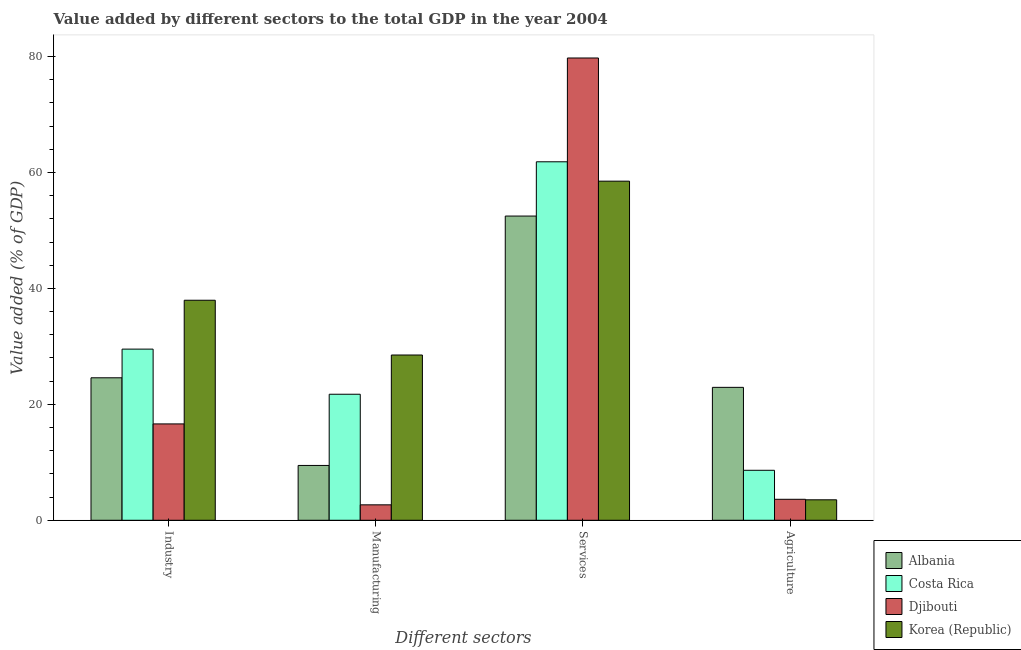How many different coloured bars are there?
Give a very brief answer. 4. How many groups of bars are there?
Make the answer very short. 4. Are the number of bars on each tick of the X-axis equal?
Your answer should be compact. Yes. What is the label of the 3rd group of bars from the left?
Keep it short and to the point. Services. What is the value added by services sector in Costa Rica?
Make the answer very short. 61.85. Across all countries, what is the maximum value added by manufacturing sector?
Offer a terse response. 28.51. Across all countries, what is the minimum value added by services sector?
Provide a short and direct response. 52.49. In which country was the value added by manufacturing sector minimum?
Keep it short and to the point. Djibouti. What is the total value added by agricultural sector in the graph?
Provide a short and direct response. 38.7. What is the difference between the value added by manufacturing sector in Costa Rica and that in Korea (Republic)?
Provide a short and direct response. -6.77. What is the difference between the value added by services sector in Djibouti and the value added by agricultural sector in Costa Rica?
Keep it short and to the point. 71.14. What is the average value added by industrial sector per country?
Offer a terse response. 27.17. What is the difference between the value added by agricultural sector and value added by industrial sector in Korea (Republic)?
Your response must be concise. -34.43. What is the ratio of the value added by industrial sector in Costa Rica to that in Albania?
Keep it short and to the point. 1.2. Is the value added by manufacturing sector in Costa Rica less than that in Djibouti?
Offer a very short reply. No. Is the difference between the value added by manufacturing sector in Djibouti and Albania greater than the difference between the value added by agricultural sector in Djibouti and Albania?
Ensure brevity in your answer.  Yes. What is the difference between the highest and the second highest value added by manufacturing sector?
Provide a short and direct response. 6.77. What is the difference between the highest and the lowest value added by manufacturing sector?
Ensure brevity in your answer.  25.85. In how many countries, is the value added by agricultural sector greater than the average value added by agricultural sector taken over all countries?
Make the answer very short. 1. What does the 1st bar from the left in Industry represents?
Make the answer very short. Albania. What does the 4th bar from the right in Manufacturing represents?
Offer a terse response. Albania. How many countries are there in the graph?
Provide a succinct answer. 4. Are the values on the major ticks of Y-axis written in scientific E-notation?
Your answer should be compact. No. Does the graph contain grids?
Keep it short and to the point. No. How are the legend labels stacked?
Keep it short and to the point. Vertical. What is the title of the graph?
Provide a succinct answer. Value added by different sectors to the total GDP in the year 2004. What is the label or title of the X-axis?
Your answer should be compact. Different sectors. What is the label or title of the Y-axis?
Make the answer very short. Value added (% of GDP). What is the Value added (% of GDP) in Albania in Industry?
Ensure brevity in your answer.  24.58. What is the Value added (% of GDP) in Costa Rica in Industry?
Keep it short and to the point. 29.53. What is the Value added (% of GDP) of Djibouti in Industry?
Give a very brief answer. 16.62. What is the Value added (% of GDP) of Korea (Republic) in Industry?
Keep it short and to the point. 37.96. What is the Value added (% of GDP) of Albania in Manufacturing?
Ensure brevity in your answer.  9.46. What is the Value added (% of GDP) in Costa Rica in Manufacturing?
Your answer should be very brief. 21.74. What is the Value added (% of GDP) of Djibouti in Manufacturing?
Ensure brevity in your answer.  2.66. What is the Value added (% of GDP) in Korea (Republic) in Manufacturing?
Give a very brief answer. 28.51. What is the Value added (% of GDP) of Albania in Services?
Your response must be concise. 52.49. What is the Value added (% of GDP) of Costa Rica in Services?
Ensure brevity in your answer.  61.85. What is the Value added (% of GDP) in Djibouti in Services?
Make the answer very short. 79.76. What is the Value added (% of GDP) of Korea (Republic) in Services?
Make the answer very short. 58.51. What is the Value added (% of GDP) in Albania in Agriculture?
Your answer should be very brief. 22.93. What is the Value added (% of GDP) in Costa Rica in Agriculture?
Your answer should be compact. 8.62. What is the Value added (% of GDP) in Djibouti in Agriculture?
Provide a short and direct response. 3.62. What is the Value added (% of GDP) in Korea (Republic) in Agriculture?
Your answer should be compact. 3.53. Across all Different sectors, what is the maximum Value added (% of GDP) in Albania?
Give a very brief answer. 52.49. Across all Different sectors, what is the maximum Value added (% of GDP) of Costa Rica?
Provide a succinct answer. 61.85. Across all Different sectors, what is the maximum Value added (% of GDP) of Djibouti?
Provide a succinct answer. 79.76. Across all Different sectors, what is the maximum Value added (% of GDP) in Korea (Republic)?
Ensure brevity in your answer.  58.51. Across all Different sectors, what is the minimum Value added (% of GDP) of Albania?
Make the answer very short. 9.46. Across all Different sectors, what is the minimum Value added (% of GDP) of Costa Rica?
Offer a very short reply. 8.62. Across all Different sectors, what is the minimum Value added (% of GDP) of Djibouti?
Offer a very short reply. 2.66. Across all Different sectors, what is the minimum Value added (% of GDP) of Korea (Republic)?
Offer a terse response. 3.53. What is the total Value added (% of GDP) of Albania in the graph?
Your answer should be compact. 109.46. What is the total Value added (% of GDP) of Costa Rica in the graph?
Your answer should be very brief. 121.74. What is the total Value added (% of GDP) in Djibouti in the graph?
Offer a terse response. 102.66. What is the total Value added (% of GDP) of Korea (Republic) in the graph?
Provide a succinct answer. 128.51. What is the difference between the Value added (% of GDP) in Albania in Industry and that in Manufacturing?
Offer a terse response. 15.12. What is the difference between the Value added (% of GDP) of Costa Rica in Industry and that in Manufacturing?
Ensure brevity in your answer.  7.78. What is the difference between the Value added (% of GDP) in Djibouti in Industry and that in Manufacturing?
Your answer should be compact. 13.96. What is the difference between the Value added (% of GDP) of Korea (Republic) in Industry and that in Manufacturing?
Your response must be concise. 9.45. What is the difference between the Value added (% of GDP) of Albania in Industry and that in Services?
Your answer should be compact. -27.9. What is the difference between the Value added (% of GDP) in Costa Rica in Industry and that in Services?
Provide a succinct answer. -32.32. What is the difference between the Value added (% of GDP) of Djibouti in Industry and that in Services?
Your answer should be very brief. -63.14. What is the difference between the Value added (% of GDP) of Korea (Republic) in Industry and that in Services?
Offer a very short reply. -20.54. What is the difference between the Value added (% of GDP) of Albania in Industry and that in Agriculture?
Offer a very short reply. 1.65. What is the difference between the Value added (% of GDP) of Costa Rica in Industry and that in Agriculture?
Keep it short and to the point. 20.9. What is the difference between the Value added (% of GDP) in Djibouti in Industry and that in Agriculture?
Provide a short and direct response. 13. What is the difference between the Value added (% of GDP) of Korea (Republic) in Industry and that in Agriculture?
Provide a succinct answer. 34.43. What is the difference between the Value added (% of GDP) of Albania in Manufacturing and that in Services?
Give a very brief answer. -43.03. What is the difference between the Value added (% of GDP) of Costa Rica in Manufacturing and that in Services?
Make the answer very short. -40.1. What is the difference between the Value added (% of GDP) of Djibouti in Manufacturing and that in Services?
Give a very brief answer. -77.1. What is the difference between the Value added (% of GDP) of Korea (Republic) in Manufacturing and that in Services?
Offer a terse response. -29.99. What is the difference between the Value added (% of GDP) in Albania in Manufacturing and that in Agriculture?
Your answer should be compact. -13.47. What is the difference between the Value added (% of GDP) of Costa Rica in Manufacturing and that in Agriculture?
Provide a short and direct response. 13.12. What is the difference between the Value added (% of GDP) of Djibouti in Manufacturing and that in Agriculture?
Your answer should be very brief. -0.96. What is the difference between the Value added (% of GDP) in Korea (Republic) in Manufacturing and that in Agriculture?
Offer a very short reply. 24.98. What is the difference between the Value added (% of GDP) of Albania in Services and that in Agriculture?
Your answer should be very brief. 29.55. What is the difference between the Value added (% of GDP) of Costa Rica in Services and that in Agriculture?
Your answer should be compact. 53.23. What is the difference between the Value added (% of GDP) of Djibouti in Services and that in Agriculture?
Your response must be concise. 76.14. What is the difference between the Value added (% of GDP) in Korea (Republic) in Services and that in Agriculture?
Give a very brief answer. 54.98. What is the difference between the Value added (% of GDP) of Albania in Industry and the Value added (% of GDP) of Costa Rica in Manufacturing?
Provide a succinct answer. 2.84. What is the difference between the Value added (% of GDP) of Albania in Industry and the Value added (% of GDP) of Djibouti in Manufacturing?
Make the answer very short. 21.92. What is the difference between the Value added (% of GDP) of Albania in Industry and the Value added (% of GDP) of Korea (Republic) in Manufacturing?
Give a very brief answer. -3.93. What is the difference between the Value added (% of GDP) of Costa Rica in Industry and the Value added (% of GDP) of Djibouti in Manufacturing?
Offer a very short reply. 26.87. What is the difference between the Value added (% of GDP) of Costa Rica in Industry and the Value added (% of GDP) of Korea (Republic) in Manufacturing?
Keep it short and to the point. 1.01. What is the difference between the Value added (% of GDP) in Djibouti in Industry and the Value added (% of GDP) in Korea (Republic) in Manufacturing?
Your answer should be very brief. -11.89. What is the difference between the Value added (% of GDP) of Albania in Industry and the Value added (% of GDP) of Costa Rica in Services?
Offer a terse response. -37.27. What is the difference between the Value added (% of GDP) of Albania in Industry and the Value added (% of GDP) of Djibouti in Services?
Keep it short and to the point. -55.18. What is the difference between the Value added (% of GDP) in Albania in Industry and the Value added (% of GDP) in Korea (Republic) in Services?
Make the answer very short. -33.93. What is the difference between the Value added (% of GDP) in Costa Rica in Industry and the Value added (% of GDP) in Djibouti in Services?
Provide a short and direct response. -50.23. What is the difference between the Value added (% of GDP) of Costa Rica in Industry and the Value added (% of GDP) of Korea (Republic) in Services?
Provide a succinct answer. -28.98. What is the difference between the Value added (% of GDP) in Djibouti in Industry and the Value added (% of GDP) in Korea (Republic) in Services?
Provide a short and direct response. -41.88. What is the difference between the Value added (% of GDP) in Albania in Industry and the Value added (% of GDP) in Costa Rica in Agriculture?
Your answer should be compact. 15.96. What is the difference between the Value added (% of GDP) of Albania in Industry and the Value added (% of GDP) of Djibouti in Agriculture?
Your answer should be very brief. 20.96. What is the difference between the Value added (% of GDP) of Albania in Industry and the Value added (% of GDP) of Korea (Republic) in Agriculture?
Make the answer very short. 21.05. What is the difference between the Value added (% of GDP) of Costa Rica in Industry and the Value added (% of GDP) of Djibouti in Agriculture?
Your response must be concise. 25.91. What is the difference between the Value added (% of GDP) of Costa Rica in Industry and the Value added (% of GDP) of Korea (Republic) in Agriculture?
Your response must be concise. 26. What is the difference between the Value added (% of GDP) of Djibouti in Industry and the Value added (% of GDP) of Korea (Republic) in Agriculture?
Your answer should be compact. 13.09. What is the difference between the Value added (% of GDP) in Albania in Manufacturing and the Value added (% of GDP) in Costa Rica in Services?
Your answer should be compact. -52.39. What is the difference between the Value added (% of GDP) of Albania in Manufacturing and the Value added (% of GDP) of Djibouti in Services?
Provide a short and direct response. -70.3. What is the difference between the Value added (% of GDP) of Albania in Manufacturing and the Value added (% of GDP) of Korea (Republic) in Services?
Provide a short and direct response. -49.05. What is the difference between the Value added (% of GDP) of Costa Rica in Manufacturing and the Value added (% of GDP) of Djibouti in Services?
Give a very brief answer. -58.01. What is the difference between the Value added (% of GDP) of Costa Rica in Manufacturing and the Value added (% of GDP) of Korea (Republic) in Services?
Provide a short and direct response. -36.76. What is the difference between the Value added (% of GDP) in Djibouti in Manufacturing and the Value added (% of GDP) in Korea (Republic) in Services?
Offer a very short reply. -55.85. What is the difference between the Value added (% of GDP) of Albania in Manufacturing and the Value added (% of GDP) of Costa Rica in Agriculture?
Give a very brief answer. 0.83. What is the difference between the Value added (% of GDP) of Albania in Manufacturing and the Value added (% of GDP) of Djibouti in Agriculture?
Your response must be concise. 5.84. What is the difference between the Value added (% of GDP) of Albania in Manufacturing and the Value added (% of GDP) of Korea (Republic) in Agriculture?
Offer a terse response. 5.93. What is the difference between the Value added (% of GDP) in Costa Rica in Manufacturing and the Value added (% of GDP) in Djibouti in Agriculture?
Make the answer very short. 18.13. What is the difference between the Value added (% of GDP) of Costa Rica in Manufacturing and the Value added (% of GDP) of Korea (Republic) in Agriculture?
Provide a succinct answer. 18.21. What is the difference between the Value added (% of GDP) of Djibouti in Manufacturing and the Value added (% of GDP) of Korea (Republic) in Agriculture?
Provide a succinct answer. -0.87. What is the difference between the Value added (% of GDP) in Albania in Services and the Value added (% of GDP) in Costa Rica in Agriculture?
Your answer should be compact. 43.86. What is the difference between the Value added (% of GDP) of Albania in Services and the Value added (% of GDP) of Djibouti in Agriculture?
Ensure brevity in your answer.  48.87. What is the difference between the Value added (% of GDP) in Albania in Services and the Value added (% of GDP) in Korea (Republic) in Agriculture?
Provide a short and direct response. 48.96. What is the difference between the Value added (% of GDP) of Costa Rica in Services and the Value added (% of GDP) of Djibouti in Agriculture?
Offer a very short reply. 58.23. What is the difference between the Value added (% of GDP) of Costa Rica in Services and the Value added (% of GDP) of Korea (Republic) in Agriculture?
Offer a very short reply. 58.32. What is the difference between the Value added (% of GDP) of Djibouti in Services and the Value added (% of GDP) of Korea (Republic) in Agriculture?
Your answer should be compact. 76.23. What is the average Value added (% of GDP) of Albania per Different sectors?
Provide a short and direct response. 27.36. What is the average Value added (% of GDP) of Costa Rica per Different sectors?
Provide a succinct answer. 30.44. What is the average Value added (% of GDP) of Djibouti per Different sectors?
Ensure brevity in your answer.  25.67. What is the average Value added (% of GDP) in Korea (Republic) per Different sectors?
Make the answer very short. 32.13. What is the difference between the Value added (% of GDP) in Albania and Value added (% of GDP) in Costa Rica in Industry?
Provide a succinct answer. -4.95. What is the difference between the Value added (% of GDP) in Albania and Value added (% of GDP) in Djibouti in Industry?
Your response must be concise. 7.96. What is the difference between the Value added (% of GDP) in Albania and Value added (% of GDP) in Korea (Republic) in Industry?
Give a very brief answer. -13.38. What is the difference between the Value added (% of GDP) in Costa Rica and Value added (% of GDP) in Djibouti in Industry?
Keep it short and to the point. 12.91. What is the difference between the Value added (% of GDP) of Costa Rica and Value added (% of GDP) of Korea (Republic) in Industry?
Make the answer very short. -8.43. What is the difference between the Value added (% of GDP) in Djibouti and Value added (% of GDP) in Korea (Republic) in Industry?
Your answer should be very brief. -21.34. What is the difference between the Value added (% of GDP) of Albania and Value added (% of GDP) of Costa Rica in Manufacturing?
Provide a succinct answer. -12.29. What is the difference between the Value added (% of GDP) of Albania and Value added (% of GDP) of Djibouti in Manufacturing?
Keep it short and to the point. 6.8. What is the difference between the Value added (% of GDP) in Albania and Value added (% of GDP) in Korea (Republic) in Manufacturing?
Offer a terse response. -19.06. What is the difference between the Value added (% of GDP) of Costa Rica and Value added (% of GDP) of Djibouti in Manufacturing?
Keep it short and to the point. 19.08. What is the difference between the Value added (% of GDP) in Costa Rica and Value added (% of GDP) in Korea (Republic) in Manufacturing?
Keep it short and to the point. -6.77. What is the difference between the Value added (% of GDP) in Djibouti and Value added (% of GDP) in Korea (Republic) in Manufacturing?
Ensure brevity in your answer.  -25.85. What is the difference between the Value added (% of GDP) in Albania and Value added (% of GDP) in Costa Rica in Services?
Your response must be concise. -9.36. What is the difference between the Value added (% of GDP) in Albania and Value added (% of GDP) in Djibouti in Services?
Your answer should be very brief. -27.27. What is the difference between the Value added (% of GDP) in Albania and Value added (% of GDP) in Korea (Republic) in Services?
Give a very brief answer. -6.02. What is the difference between the Value added (% of GDP) in Costa Rica and Value added (% of GDP) in Djibouti in Services?
Ensure brevity in your answer.  -17.91. What is the difference between the Value added (% of GDP) of Costa Rica and Value added (% of GDP) of Korea (Republic) in Services?
Your answer should be compact. 3.34. What is the difference between the Value added (% of GDP) of Djibouti and Value added (% of GDP) of Korea (Republic) in Services?
Make the answer very short. 21.25. What is the difference between the Value added (% of GDP) of Albania and Value added (% of GDP) of Costa Rica in Agriculture?
Provide a short and direct response. 14.31. What is the difference between the Value added (% of GDP) of Albania and Value added (% of GDP) of Djibouti in Agriculture?
Offer a terse response. 19.31. What is the difference between the Value added (% of GDP) of Albania and Value added (% of GDP) of Korea (Republic) in Agriculture?
Give a very brief answer. 19.4. What is the difference between the Value added (% of GDP) of Costa Rica and Value added (% of GDP) of Djibouti in Agriculture?
Give a very brief answer. 5. What is the difference between the Value added (% of GDP) of Costa Rica and Value added (% of GDP) of Korea (Republic) in Agriculture?
Offer a very short reply. 5.09. What is the difference between the Value added (% of GDP) in Djibouti and Value added (% of GDP) in Korea (Republic) in Agriculture?
Give a very brief answer. 0.09. What is the ratio of the Value added (% of GDP) of Albania in Industry to that in Manufacturing?
Your response must be concise. 2.6. What is the ratio of the Value added (% of GDP) in Costa Rica in Industry to that in Manufacturing?
Ensure brevity in your answer.  1.36. What is the ratio of the Value added (% of GDP) of Djibouti in Industry to that in Manufacturing?
Keep it short and to the point. 6.25. What is the ratio of the Value added (% of GDP) of Korea (Republic) in Industry to that in Manufacturing?
Provide a short and direct response. 1.33. What is the ratio of the Value added (% of GDP) in Albania in Industry to that in Services?
Your response must be concise. 0.47. What is the ratio of the Value added (% of GDP) of Costa Rica in Industry to that in Services?
Your answer should be compact. 0.48. What is the ratio of the Value added (% of GDP) of Djibouti in Industry to that in Services?
Offer a terse response. 0.21. What is the ratio of the Value added (% of GDP) in Korea (Republic) in Industry to that in Services?
Provide a succinct answer. 0.65. What is the ratio of the Value added (% of GDP) of Albania in Industry to that in Agriculture?
Your response must be concise. 1.07. What is the ratio of the Value added (% of GDP) of Costa Rica in Industry to that in Agriculture?
Offer a terse response. 3.42. What is the ratio of the Value added (% of GDP) in Djibouti in Industry to that in Agriculture?
Provide a succinct answer. 4.59. What is the ratio of the Value added (% of GDP) of Korea (Republic) in Industry to that in Agriculture?
Give a very brief answer. 10.75. What is the ratio of the Value added (% of GDP) of Albania in Manufacturing to that in Services?
Ensure brevity in your answer.  0.18. What is the ratio of the Value added (% of GDP) in Costa Rica in Manufacturing to that in Services?
Keep it short and to the point. 0.35. What is the ratio of the Value added (% of GDP) in Djibouti in Manufacturing to that in Services?
Give a very brief answer. 0.03. What is the ratio of the Value added (% of GDP) in Korea (Republic) in Manufacturing to that in Services?
Provide a succinct answer. 0.49. What is the ratio of the Value added (% of GDP) of Albania in Manufacturing to that in Agriculture?
Offer a very short reply. 0.41. What is the ratio of the Value added (% of GDP) of Costa Rica in Manufacturing to that in Agriculture?
Your answer should be very brief. 2.52. What is the ratio of the Value added (% of GDP) in Djibouti in Manufacturing to that in Agriculture?
Offer a terse response. 0.74. What is the ratio of the Value added (% of GDP) in Korea (Republic) in Manufacturing to that in Agriculture?
Your answer should be very brief. 8.08. What is the ratio of the Value added (% of GDP) of Albania in Services to that in Agriculture?
Provide a succinct answer. 2.29. What is the ratio of the Value added (% of GDP) in Costa Rica in Services to that in Agriculture?
Offer a terse response. 7.17. What is the ratio of the Value added (% of GDP) of Djibouti in Services to that in Agriculture?
Provide a succinct answer. 22.04. What is the ratio of the Value added (% of GDP) of Korea (Republic) in Services to that in Agriculture?
Give a very brief answer. 16.57. What is the difference between the highest and the second highest Value added (% of GDP) of Albania?
Your response must be concise. 27.9. What is the difference between the highest and the second highest Value added (% of GDP) in Costa Rica?
Offer a very short reply. 32.32. What is the difference between the highest and the second highest Value added (% of GDP) of Djibouti?
Make the answer very short. 63.14. What is the difference between the highest and the second highest Value added (% of GDP) in Korea (Republic)?
Keep it short and to the point. 20.54. What is the difference between the highest and the lowest Value added (% of GDP) of Albania?
Give a very brief answer. 43.03. What is the difference between the highest and the lowest Value added (% of GDP) of Costa Rica?
Offer a very short reply. 53.23. What is the difference between the highest and the lowest Value added (% of GDP) of Djibouti?
Offer a terse response. 77.1. What is the difference between the highest and the lowest Value added (% of GDP) in Korea (Republic)?
Offer a terse response. 54.98. 